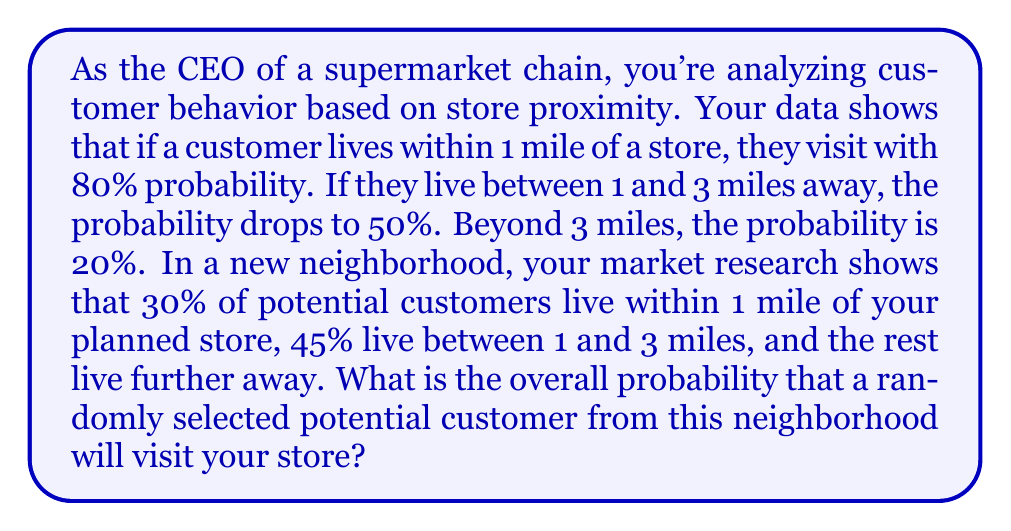Give your solution to this math problem. Let's approach this step-by-step using the law of total probability:

1) Define events:
   A: Customer visits the store
   B1: Customer lives within 1 mile
   B2: Customer lives between 1 and 3 miles
   B3: Customer lives beyond 3 miles

2) Given probabilities:
   $P(A|B1) = 0.80$
   $P(A|B2) = 0.50$
   $P(A|B3) = 0.20$
   $P(B1) = 0.30$
   $P(B2) = 0.45$
   $P(B3) = 1 - 0.30 - 0.45 = 0.25$

3) Use the law of total probability:
   $$P(A) = P(A|B1)P(B1) + P(A|B2)P(B2) + P(A|B3)P(B3)$$

4) Substitute the values:
   $$P(A) = (0.80)(0.30) + (0.50)(0.45) + (0.20)(0.25)$$

5) Calculate:
   $$P(A) = 0.24 + 0.225 + 0.05 = 0.515$$

Therefore, the overall probability that a randomly selected potential customer will visit the store is 0.515 or 51.5%.
Answer: 0.515 or 51.5% 